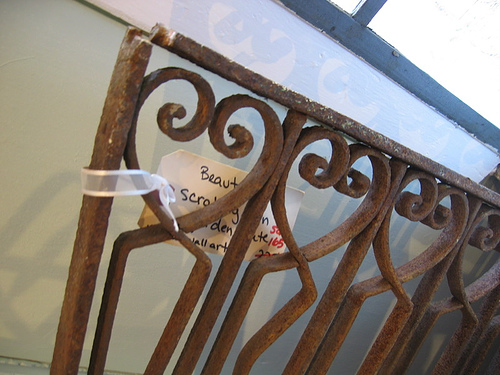<image>
Is there a wall behind the fence? Yes. From this viewpoint, the wall is positioned behind the fence, with the fence partially or fully occluding the wall. Is the sign on the gate? Yes. Looking at the image, I can see the sign is positioned on top of the gate, with the gate providing support. 